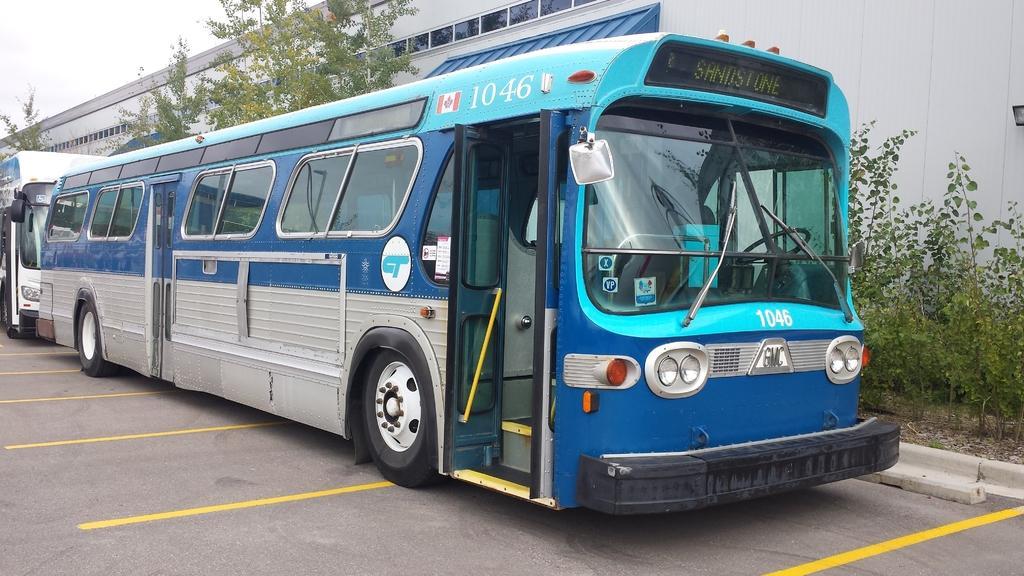How would you summarize this image in a sentence or two? In this picture I can see couple of buses and I can see trees, plants and a building and I can see sky. 